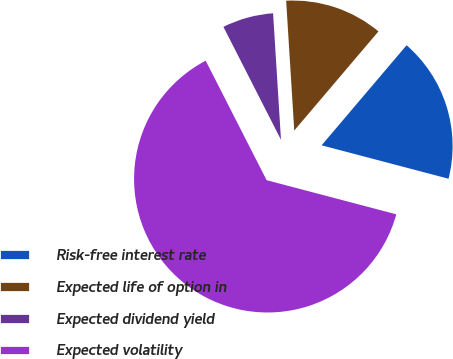Convert chart to OTSL. <chart><loc_0><loc_0><loc_500><loc_500><pie_chart><fcel>Risk-free interest rate<fcel>Expected life of option in<fcel>Expected dividend yield<fcel>Expected volatility<nl><fcel>17.89%<fcel>12.2%<fcel>6.51%<fcel>63.4%<nl></chart> 